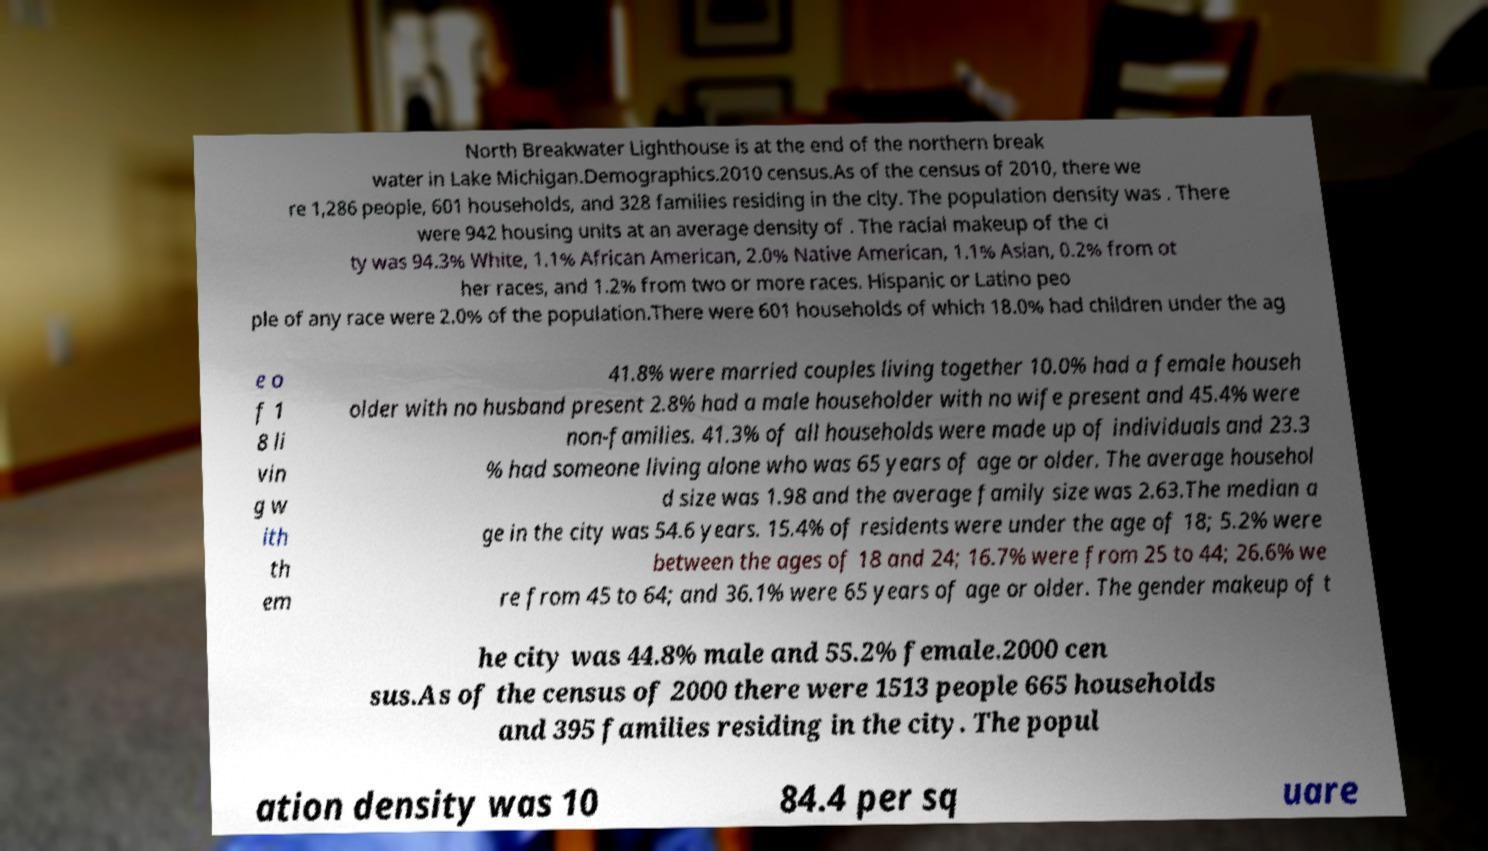Could you assist in decoding the text presented in this image and type it out clearly? North Breakwater Lighthouse is at the end of the northern break water in Lake Michigan.Demographics.2010 census.As of the census of 2010, there we re 1,286 people, 601 households, and 328 families residing in the city. The population density was . There were 942 housing units at an average density of . The racial makeup of the ci ty was 94.3% White, 1.1% African American, 2.0% Native American, 1.1% Asian, 0.2% from ot her races, and 1.2% from two or more races. Hispanic or Latino peo ple of any race were 2.0% of the population.There were 601 households of which 18.0% had children under the ag e o f 1 8 li vin g w ith th em 41.8% were married couples living together 10.0% had a female househ older with no husband present 2.8% had a male householder with no wife present and 45.4% were non-families. 41.3% of all households were made up of individuals and 23.3 % had someone living alone who was 65 years of age or older. The average househol d size was 1.98 and the average family size was 2.63.The median a ge in the city was 54.6 years. 15.4% of residents were under the age of 18; 5.2% were between the ages of 18 and 24; 16.7% were from 25 to 44; 26.6% we re from 45 to 64; and 36.1% were 65 years of age or older. The gender makeup of t he city was 44.8% male and 55.2% female.2000 cen sus.As of the census of 2000 there were 1513 people 665 households and 395 families residing in the city. The popul ation density was 10 84.4 per sq uare 